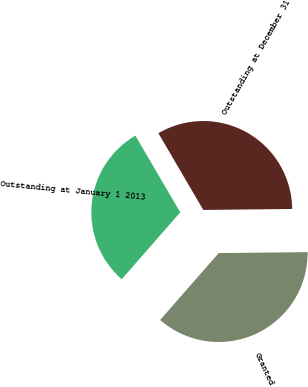Convert chart to OTSL. <chart><loc_0><loc_0><loc_500><loc_500><pie_chart><fcel>Outstanding at January 1 2013<fcel>Granted<fcel>Outstanding at December 31<nl><fcel>30.14%<fcel>36.61%<fcel>33.25%<nl></chart> 